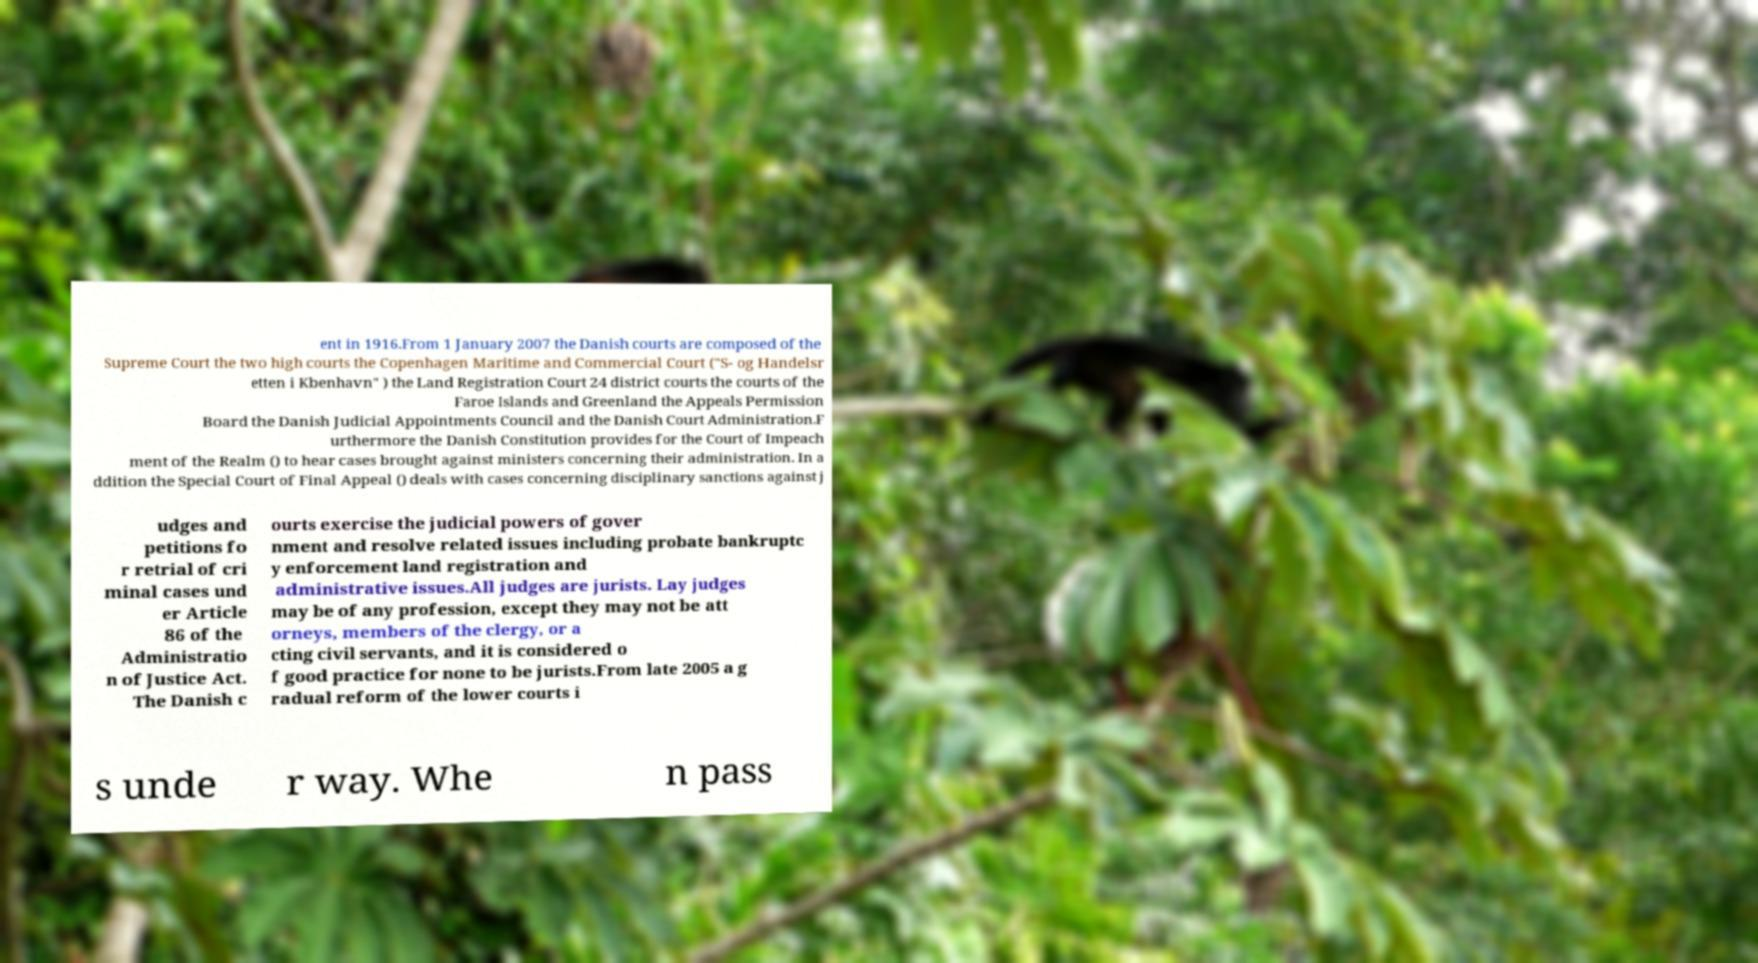Can you read and provide the text displayed in the image?This photo seems to have some interesting text. Can you extract and type it out for me? ent in 1916.From 1 January 2007 the Danish courts are composed of the Supreme Court the two high courts the Copenhagen Maritime and Commercial Court ("S- og Handelsr etten i Kbenhavn" ) the Land Registration Court 24 district courts the courts of the Faroe Islands and Greenland the Appeals Permission Board the Danish Judicial Appointments Council and the Danish Court Administration.F urthermore the Danish Constitution provides for the Court of Impeach ment of the Realm () to hear cases brought against ministers concerning their administration. In a ddition the Special Court of Final Appeal () deals with cases concerning disciplinary sanctions against j udges and petitions fo r retrial of cri minal cases und er Article 86 of the Administratio n of Justice Act. The Danish c ourts exercise the judicial powers of gover nment and resolve related issues including probate bankruptc y enforcement land registration and administrative issues.All judges are jurists. Lay judges may be of any profession, except they may not be att orneys, members of the clergy, or a cting civil servants, and it is considered o f good practice for none to be jurists.From late 2005 a g radual reform of the lower courts i s unde r way. Whe n pass 